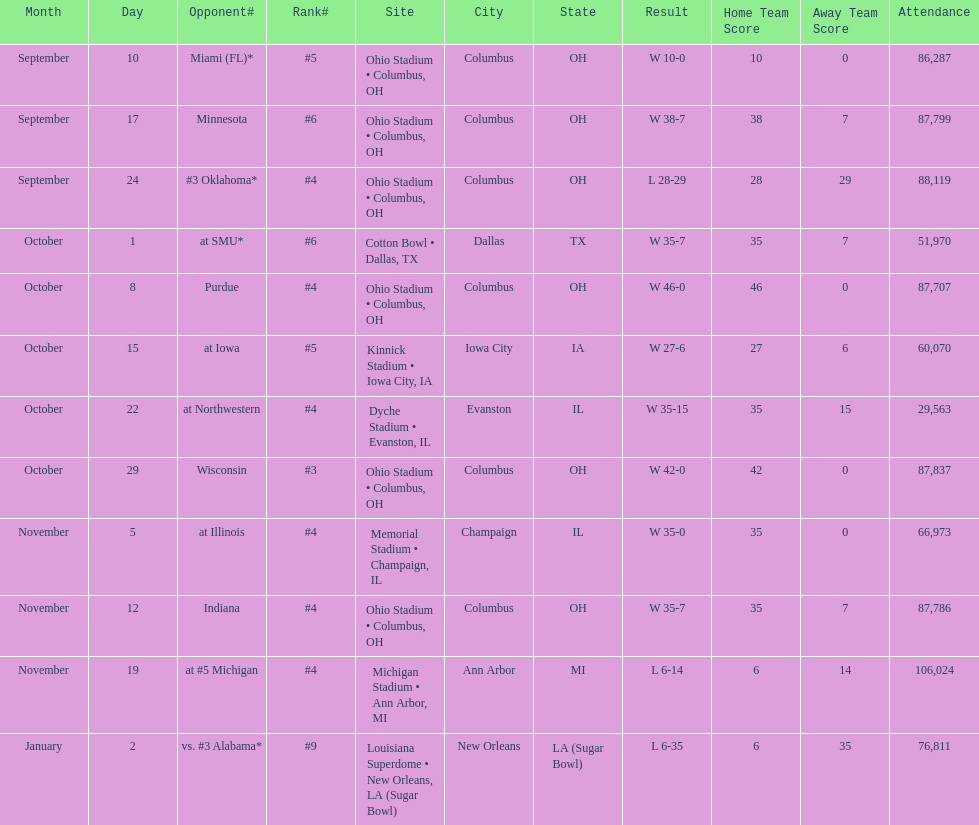How many dates are on the chart 12. 